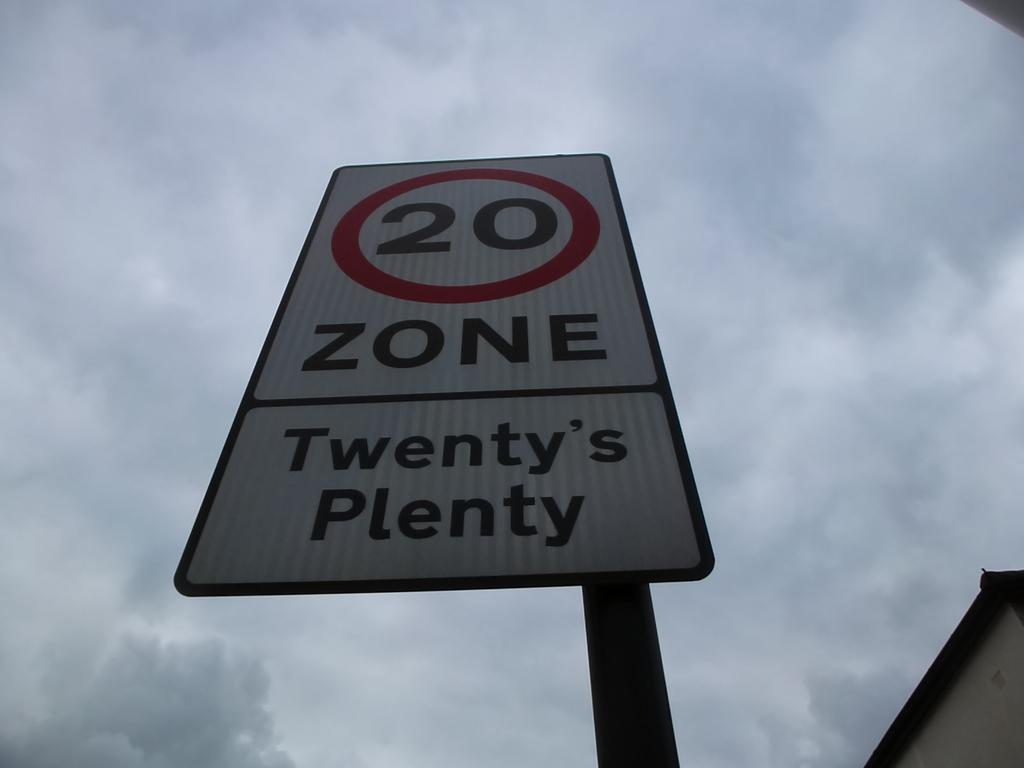What is the main subject in the center of the image? There is a sign board in the center of the image. What can be seen at the top of the image? The sky is visible at the top of the image. Where is the coat hanging in the alley in the image? There is no coat or alley present in the image; it only features a sign board and the sky. 